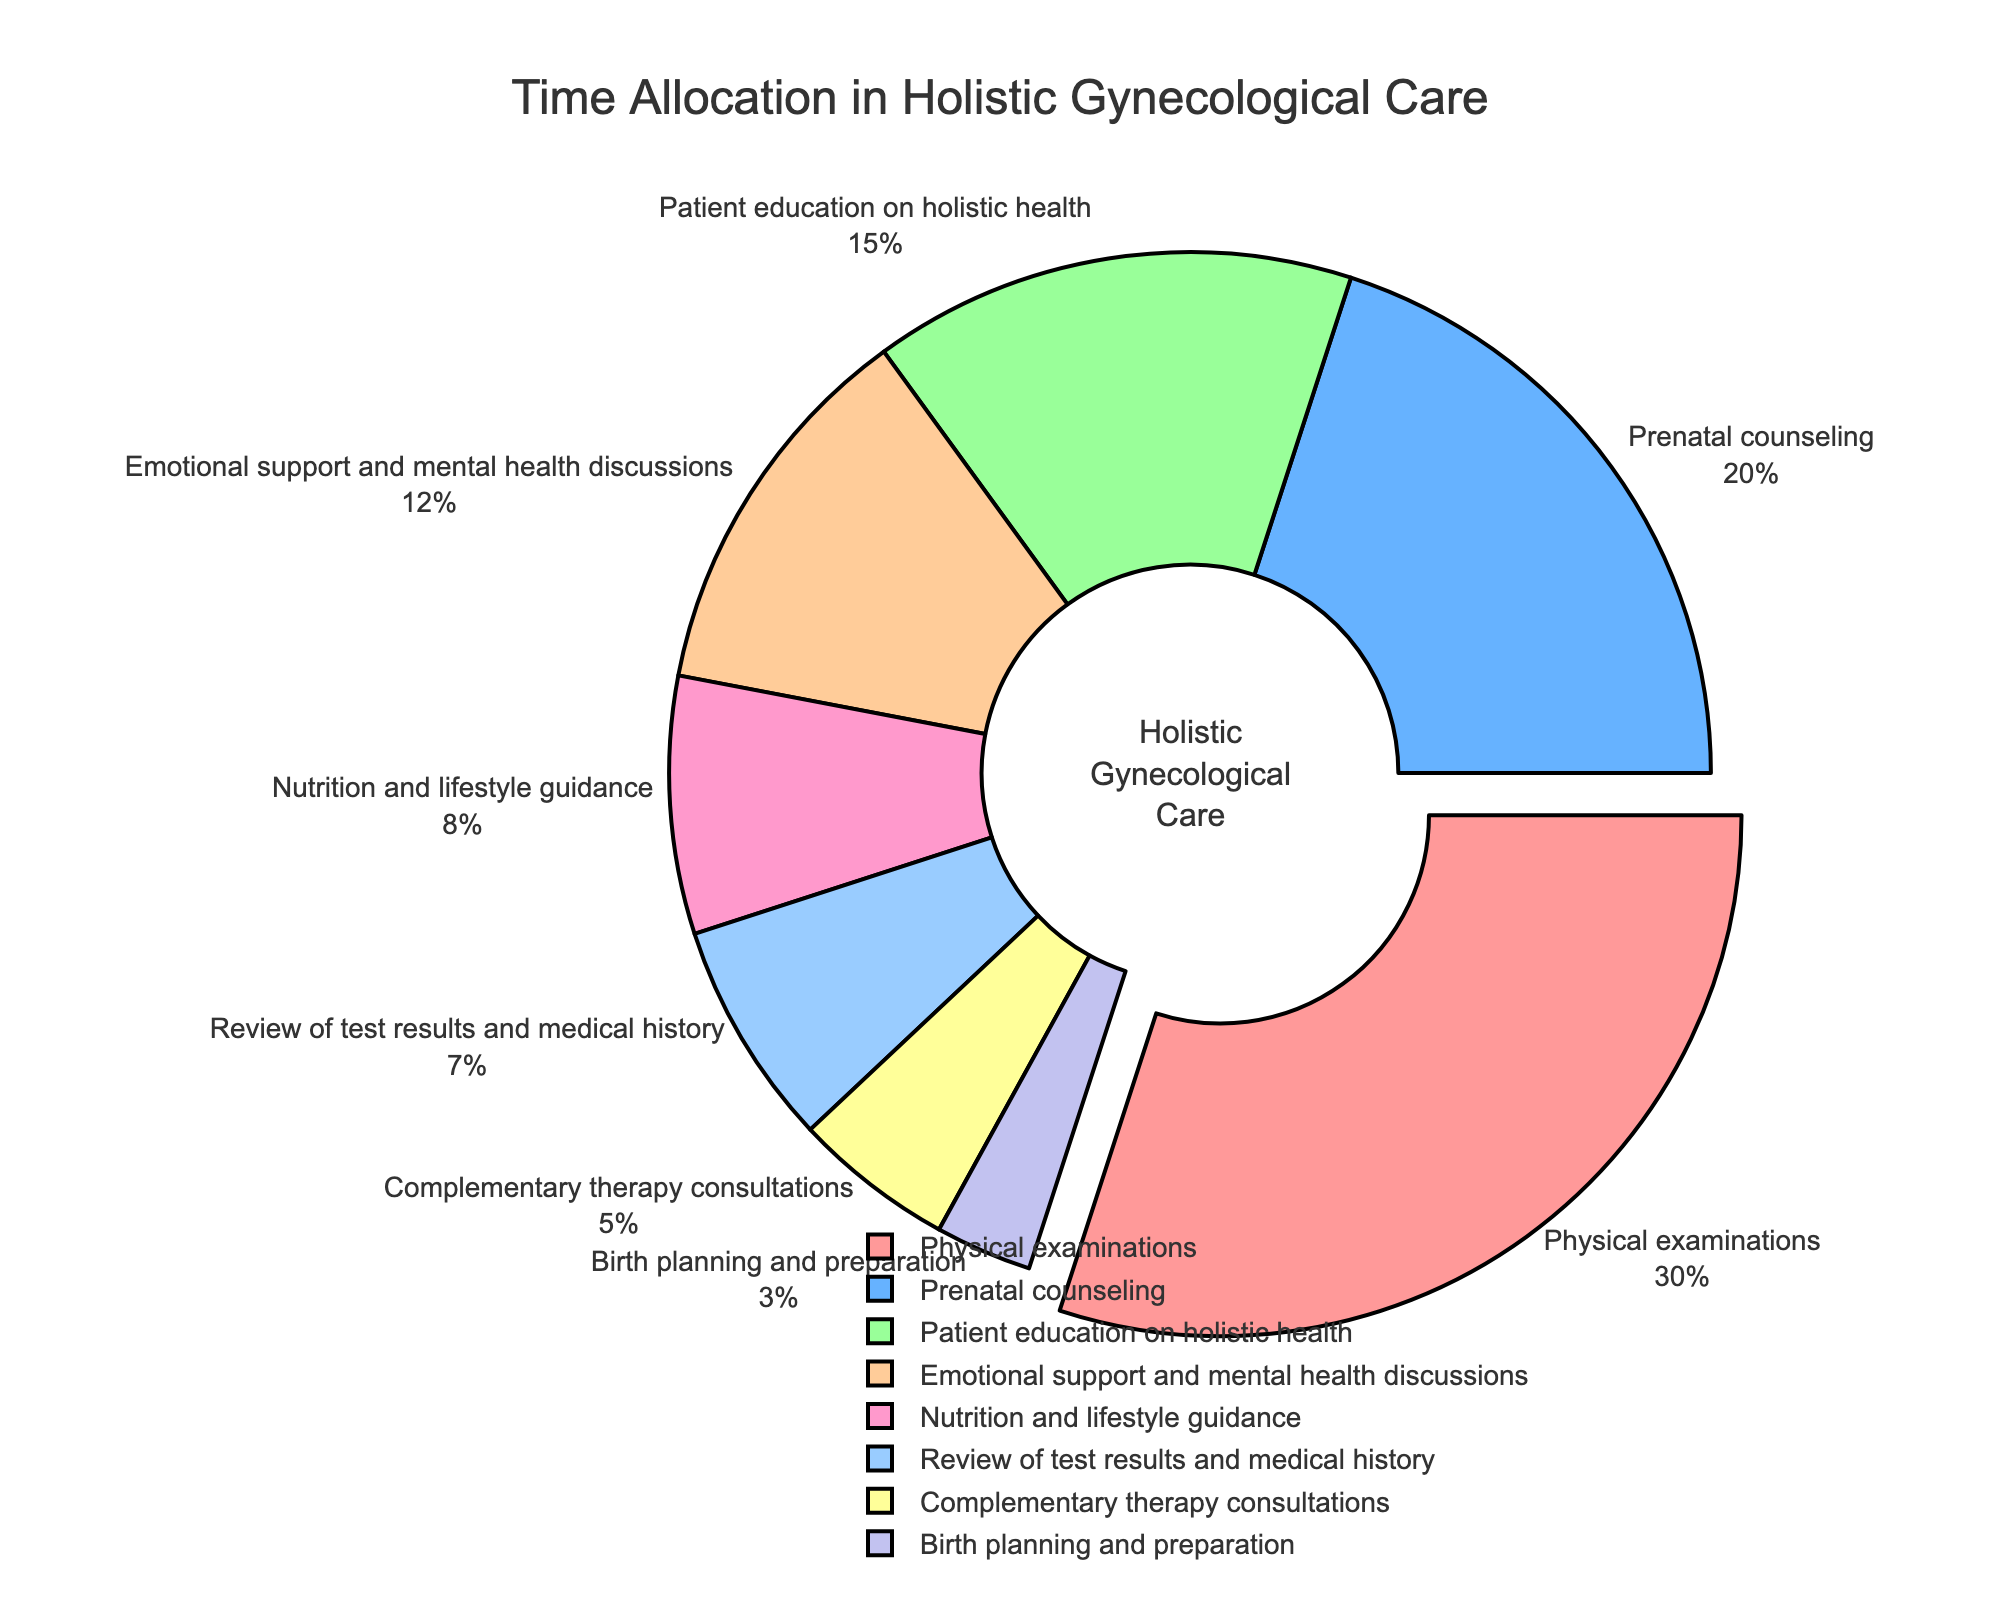What activity has the largest allocation of time? The pie chart shows different activities with varying allocations. The activity with the largest part of the pie is physical examinations.
Answer: Physical examinations What is the combined percentage of time spent on emotional support, nutrition guidance, and review of test results? Add the percentages of the three activities: Emotional support (12%), Nutrition and lifestyle guidance (8%), Review of test results and medical history (7%). The combined percentage is 12% + 8% + 7% = 27%.
Answer: 27% Is the percentage of time spent on prenatal counseling greater than that on patient education on holistic health? Compare the percentages for prenatal counseling (20%) and patient education on holistic health (15%). Prenatal counseling has a greater percentage (20%) than patient education (15%).
Answer: Yes How does the time allocated for complementary therapy consultations compare with birth planning and preparation? Complementary therapy consultations are allocated 5% of the time, while birth planning and preparation are allocated 3%. Therefore, complementary therapy consultations have a greater allocation than birth planning and preparation.
Answer: Greater Which activities combined make up more than half of the total time allocation? The activities and their percentages are: Physical examinations (30%), Prenatal counseling (20%), Patient education on holistic health (15%), Emotional support (12%). To find which combinations make up more than 50%, start adding the largest percentages. Physical examinations 30% + Prenatal counseling 20% = 50%. Adding another activity makes it greater than 50%.
Answer: Physical examinations and Prenatal counseling What is the difference in time allocation between the highest and lowest activities? The highest allocation is for physical examinations (30%) and the lowest is for birth planning and preparation (3%). The difference is 30% - 3% = 27%.
Answer: 27% Which activities are represented by shades of red in the pie chart? The pie chart uses specific colors, and activities represented by shades of red are identified by looking at the visual attributes. Physical examinations are a shade of red (most prominent).
Answer: Physical examinations What is the total percentage of time spent on activities related to direct patient interaction (physical examinations, counseling, emotional support)? Add the percentages of physical examinations (30%), prenatal counseling (20%), and emotional support (12%). The total is 30% + 20% + 12% = 62%.
Answer: 62% If you were to visually identify the activity with the smallest allocation, which one would it be and what is its percentage? The smallest segment in the pie chart represents birth planning and preparation which is given 3% of the time.
Answer: Birth planning and preparation, 3% 